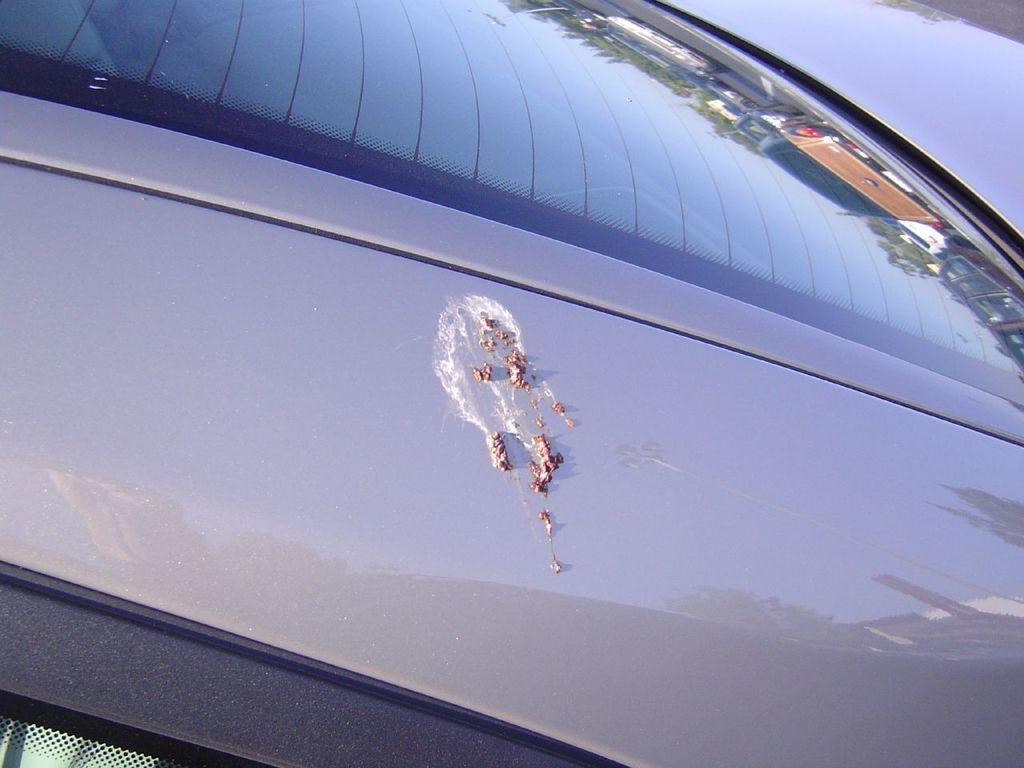What type of object is partially visible in the image? There is a part of a vehicle in the image. What other object is present in the image? There is a mirror in the image. What can be seen in the reflection of the mirror? The reflection of trees and vehicles is visible on the mirror. Where is the goat standing in the image? There is no goat present in the image. What type of cake is being served in the image? There is no cake present in the image. 